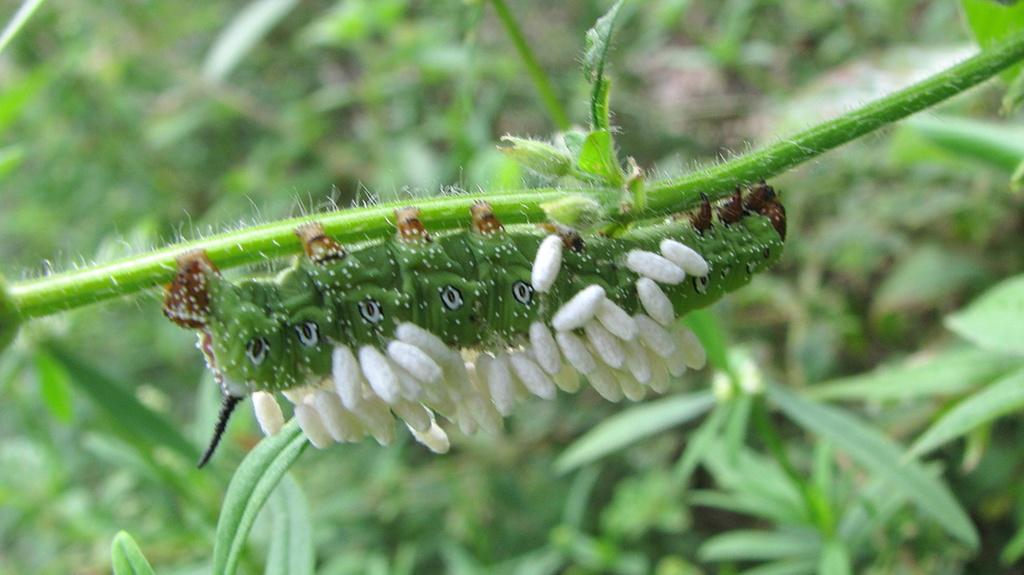What is present on the plant in the image? There is an insect on a plant in the image. What else can be seen in the image besides the insect and plant? There are other plants in the image. Can you describe the background of the image? The background of the image is blurred. How many oranges are hanging from the roof in the image? There are no oranges or roof present in the image. 